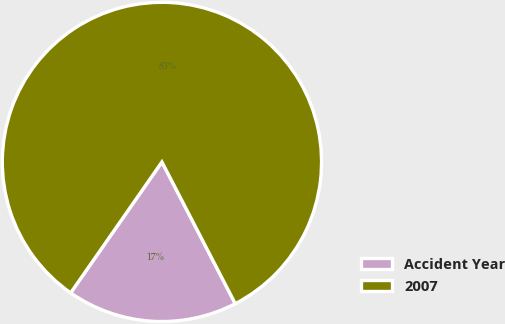Convert chart. <chart><loc_0><loc_0><loc_500><loc_500><pie_chart><fcel>Accident Year<fcel>2007<nl><fcel>17.29%<fcel>82.71%<nl></chart> 